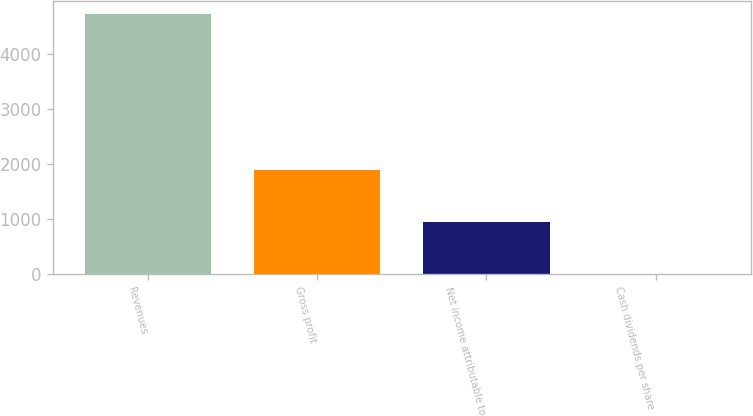Convert chart to OTSL. <chart><loc_0><loc_0><loc_500><loc_500><bar_chart><fcel>Revenues<fcel>Gross profit<fcel>Net income attributable to<fcel>Cash dividends per share<nl><fcel>4734<fcel>1893.68<fcel>946.9<fcel>0.12<nl></chart> 